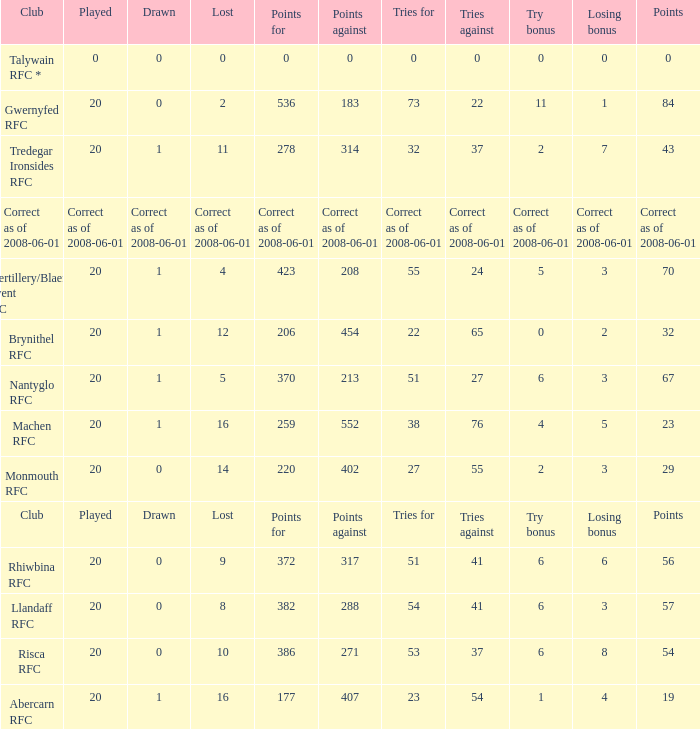What club had 56 points? Rhiwbina RFC. 